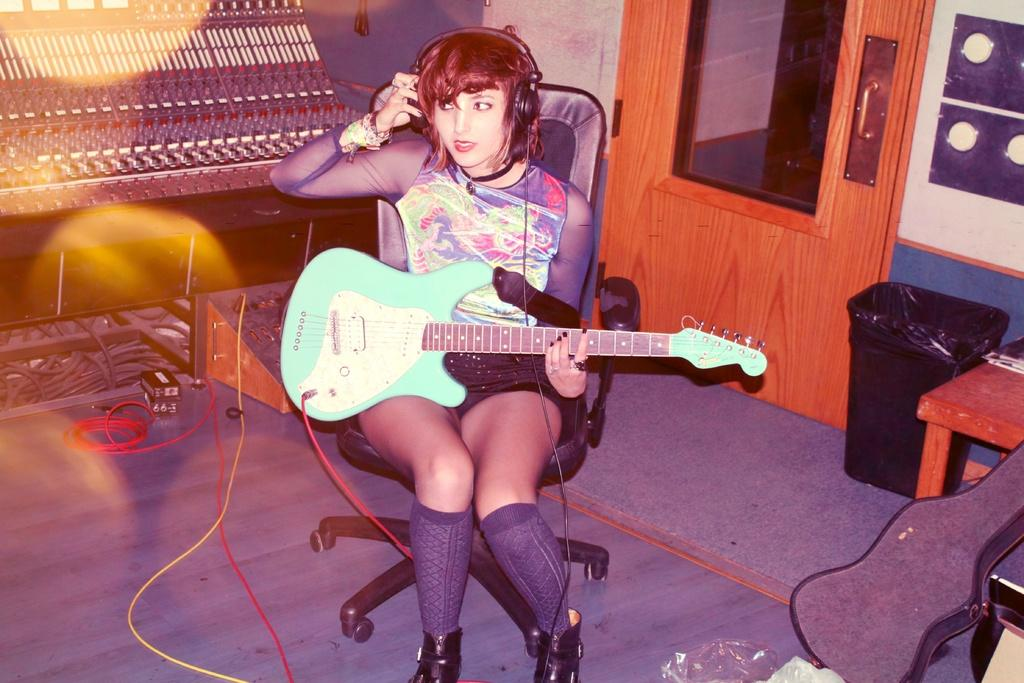Who is the main subject in the image? There is a woman in the image. What is the woman doing in the image? The woman is sitting in a chair and holding a guitar. What can be seen in the background of the image? There is a wooden door, a wall, and a table in the background of the image. What type of pencil is the woman using to play the guitar in the image? There is no pencil present in the image, and the woman is not using any pencil to play the guitar. 